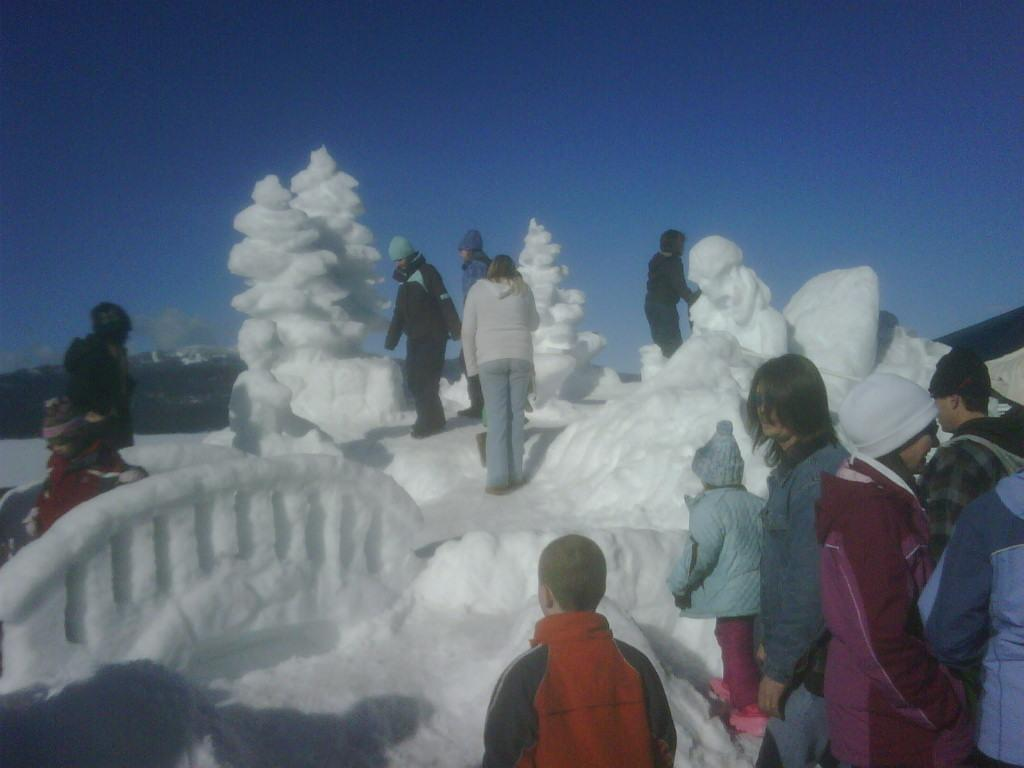Who or what can be seen in the image? There are people in the image. What type of unique architecture is present in the image? There is architecture made up of ice in the image. What other artistic elements can be seen in the image? There are sculptures in the image. How are the people interacting with the sculptures? There are people around the sculptures. What is the price of the sculpture in the image? The provided facts do not mention any prices, so it is impossible to determine the price of the sculpture in the image. 